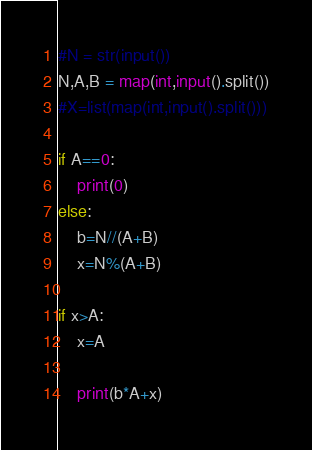<code> <loc_0><loc_0><loc_500><loc_500><_Python_>#N = str(input())
N,A,B = map(int,input().split())
#X=list(map(int,input().split()))

if A==0:
    print(0)
else:
    b=N//(A+B)
    x=N%(A+B)

if x>A:
    x=A

    print(b*A+x)
</code> 